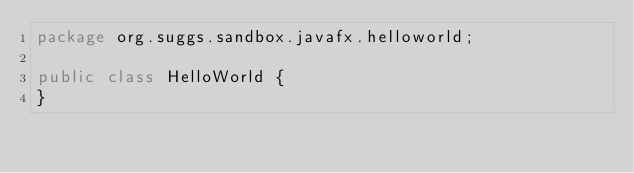<code> <loc_0><loc_0><loc_500><loc_500><_Java_>package org.suggs.sandbox.javafx.helloworld;

public class HelloWorld {
}
</code> 